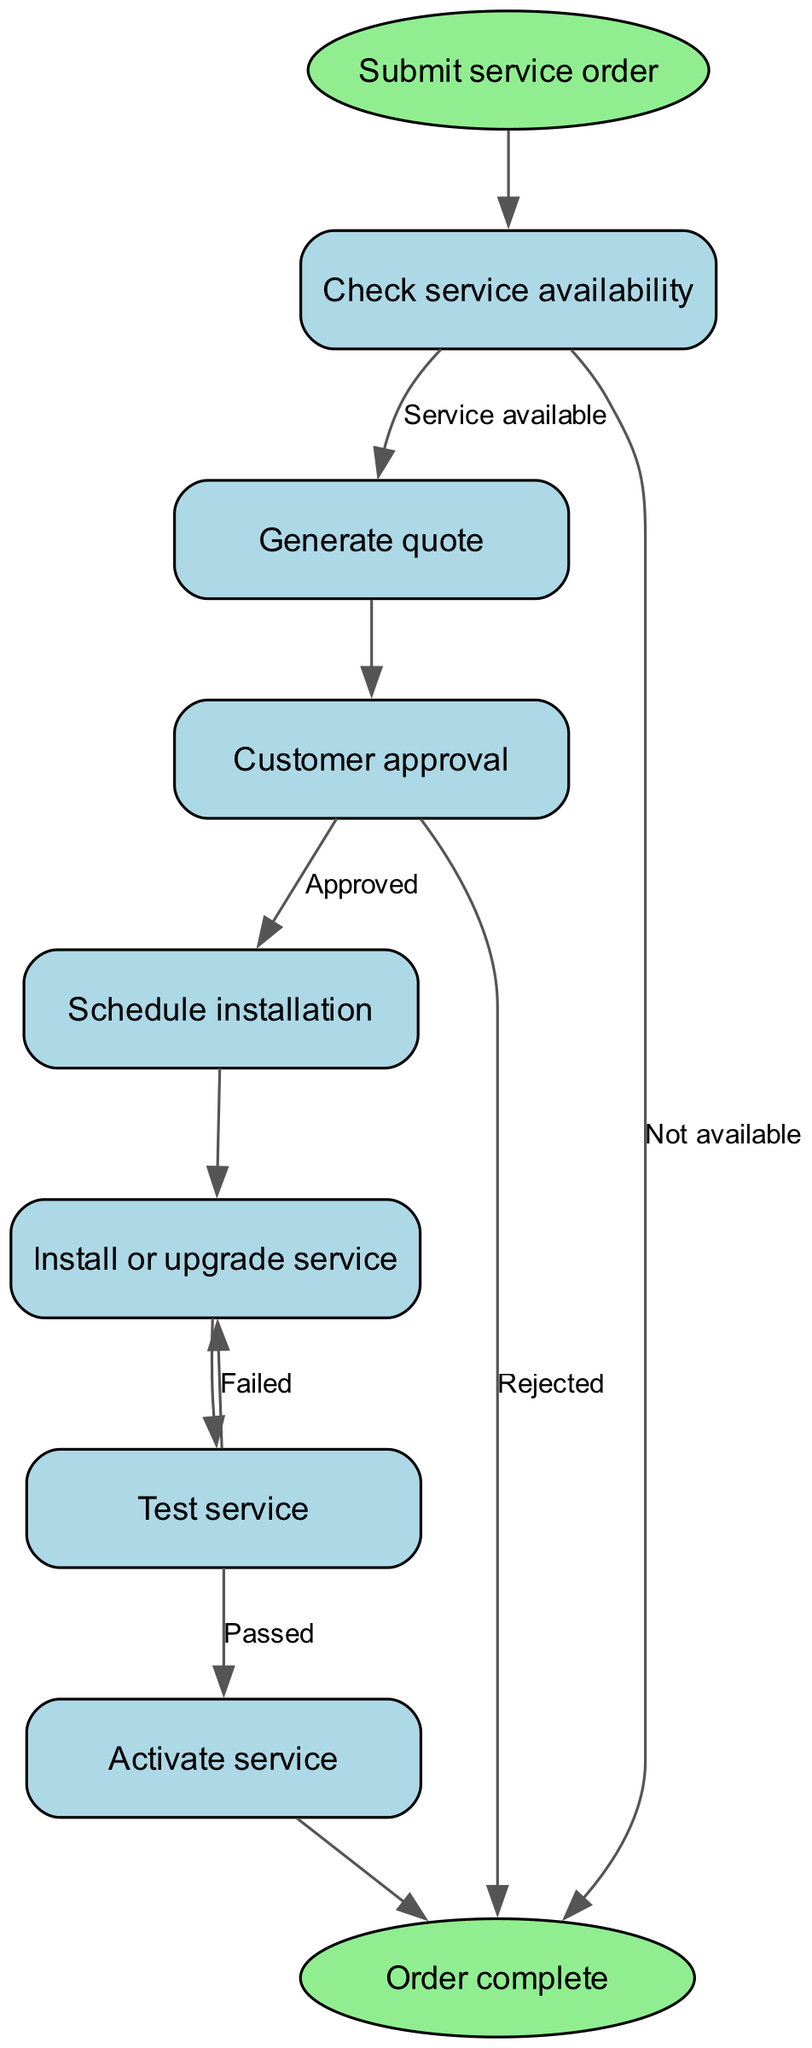What is the first step in the order processing workflow? The first step in the workflow is indicated by the "start" node, which shows that a service order must be submitted.
Answer: Submit service order How many nodes are present in the diagram? By counting the nodes listed in the data, we see that there are nine distinct nodes including start and end.
Answer: Nine Which node is connected directly to the "approval" node? The "approval" node is connected directly to the "quote" node before receiving the customer's approval.
Answer: Quote What happens if the service is not available? If the service is not available, the diagram indicates it leads directly to the "end" node, showing that the order cannot be processed further.
Answer: Order complete After customer approval, which node follows? Once the customer approves the quote, the next node in the workflow is "schedule," indicating that an installation time can be set.
Answer: Schedule installation What is the outcome if the test for service fails? If the test for the service fails, the flow diagram shows a link back to the "install" node, indicating that the installation needs to be redone.
Answer: Install or upgrade service How many edges lead from the "check" node? The "check" node has two edges leading from it: one to "quote" if the service is available and another directly to "end" if the service is not available.
Answer: Two What is the final node in the process? The final node in the workflow, indicating the completion of the order process, is labeled as "end."
Answer: Order complete What is required to proceed from "quote" to "approval"? To proceed from "quote" to "approval," the quote must be generated first, as indicated by the direct connection between these two nodes.
Answer: Generate quote 